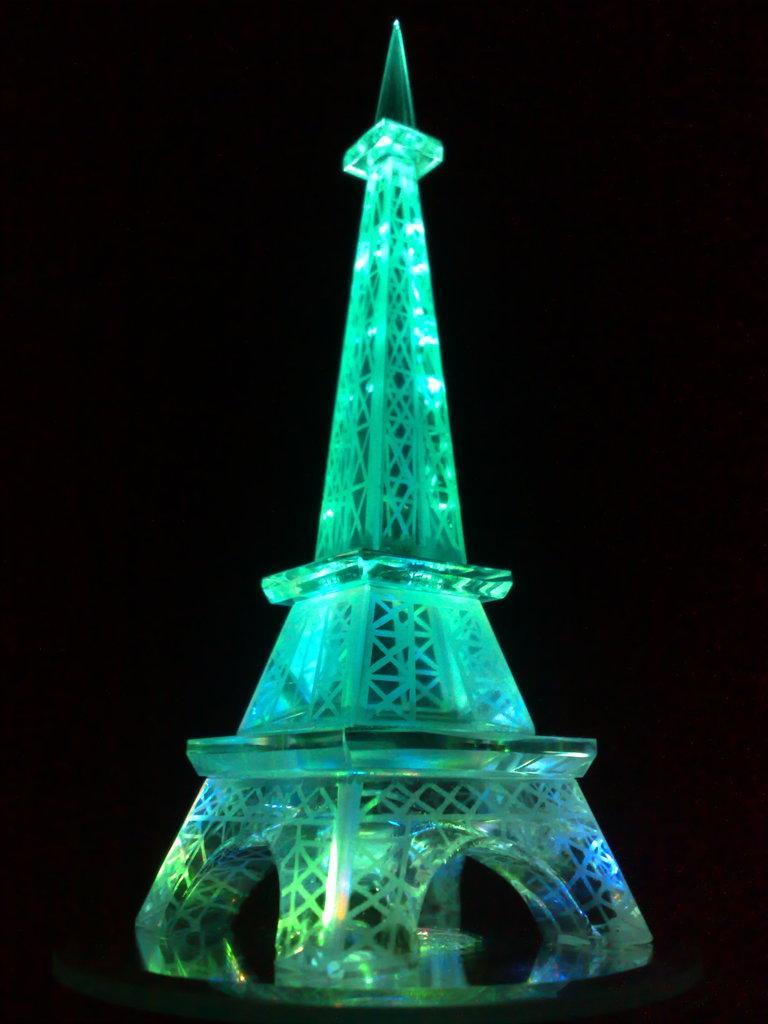Can you describe this image briefly? In this picture we can see a toy tower with lights and in the background it is dark. 